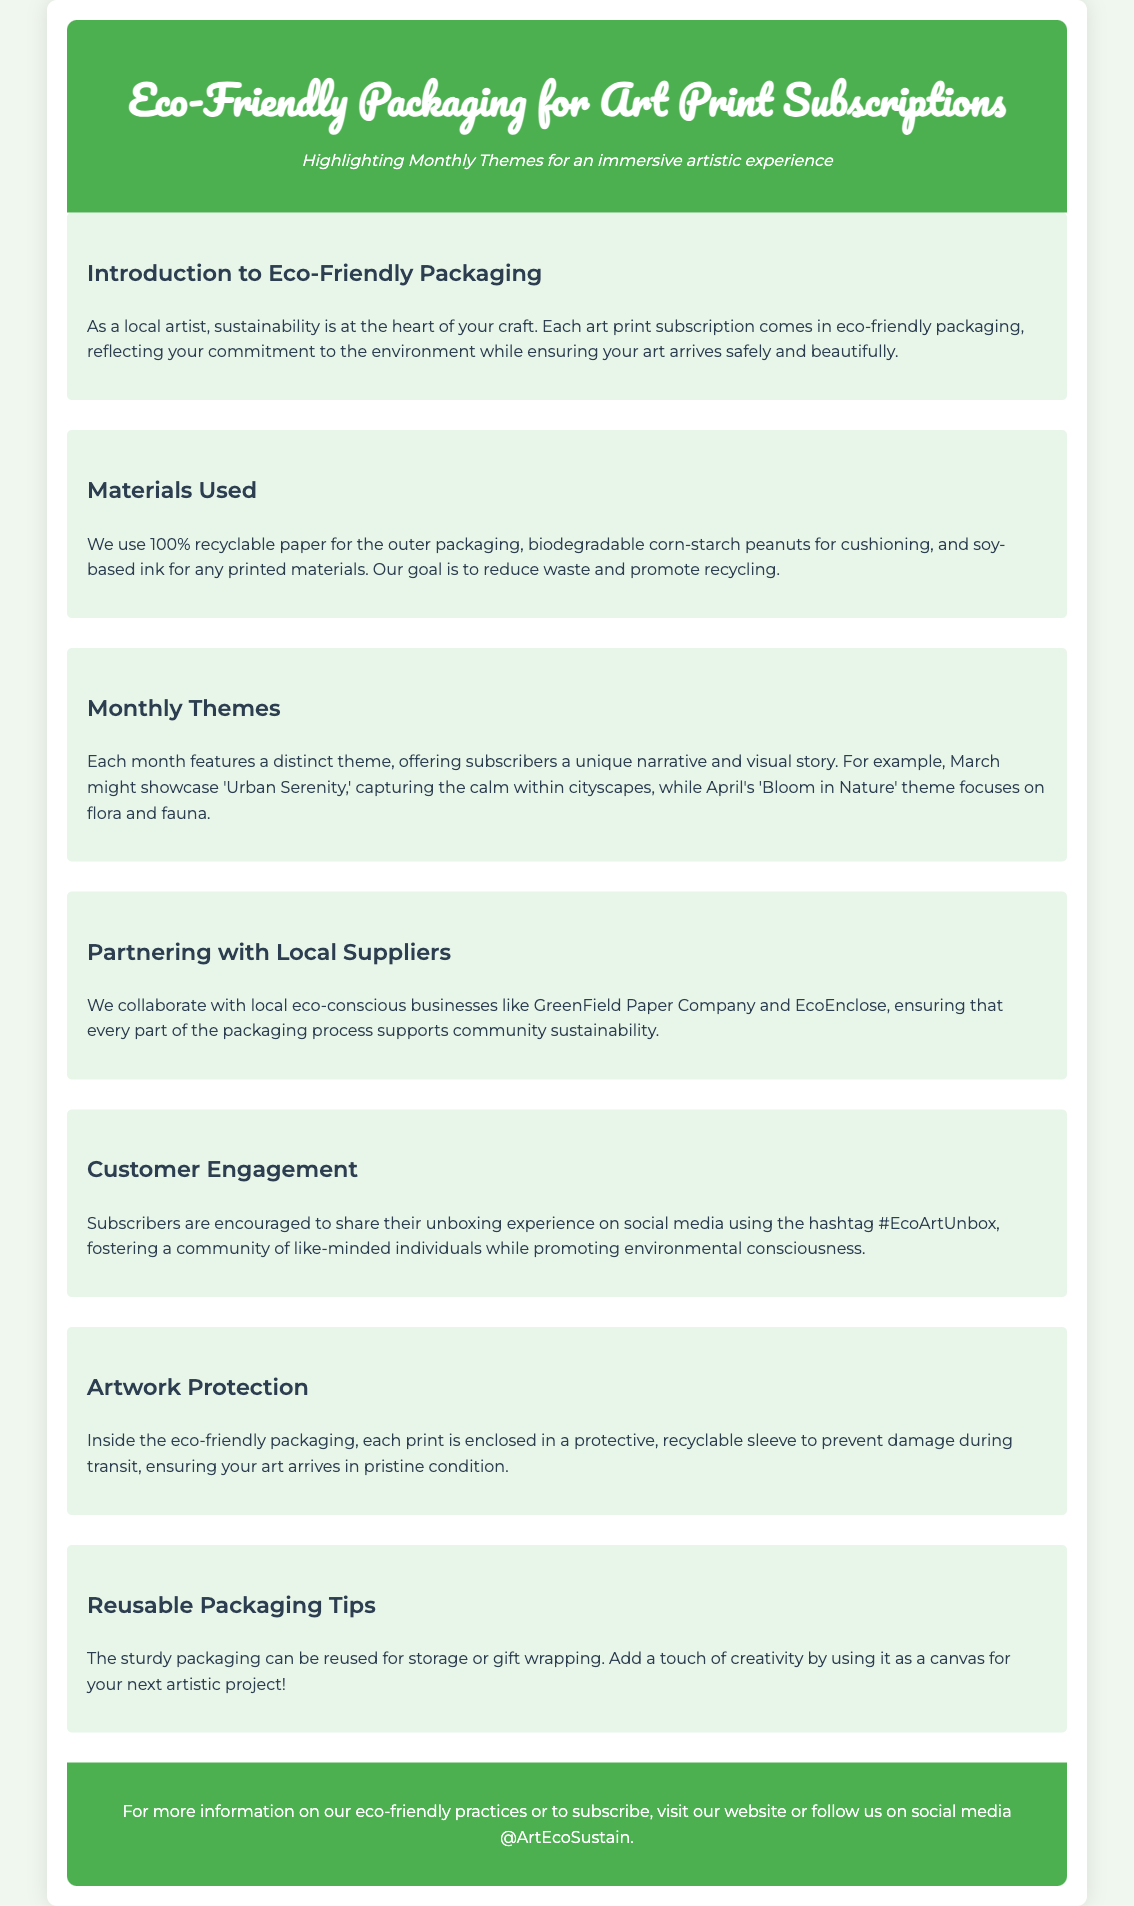What materials are used for packaging? The materials used for packaging include 100% recyclable paper, biodegradable corn-starch peanuts, and soy-based ink.
Answer: 100% recyclable paper, biodegradable corn-starch peanuts, soy-based ink What is the theme for March? The theme for March is described in the document as 'Urban Serenity.'
Answer: Urban Serenity Which eco-conscious businesses are partnered with? The document mentions partnerships with GreenField Paper Company and EcoEnclose.
Answer: GreenField Paper Company, EcoEnclose What is the unboxing hashtag? The hashtag for sharing unboxing experiences is #EcoArtUnbox.
Answer: #EcoArtUnbox How is artwork protected during transit? Each print is enclosed in a protective, recyclable sleeve to prevent damage.
Answer: Protective, recyclable sleeve What can the sturdy packaging be reused for? The document suggests that the packaging can be reused for storage or gift wrapping.
Answer: Storage or gift wrapping What is the color of the header background? The header background color is specified in the document as #4CAF50.
Answer: #4CAF50 How many months are highlighted in the themes? The document outlines themes for at least two months: March and April.
Answer: Two months 